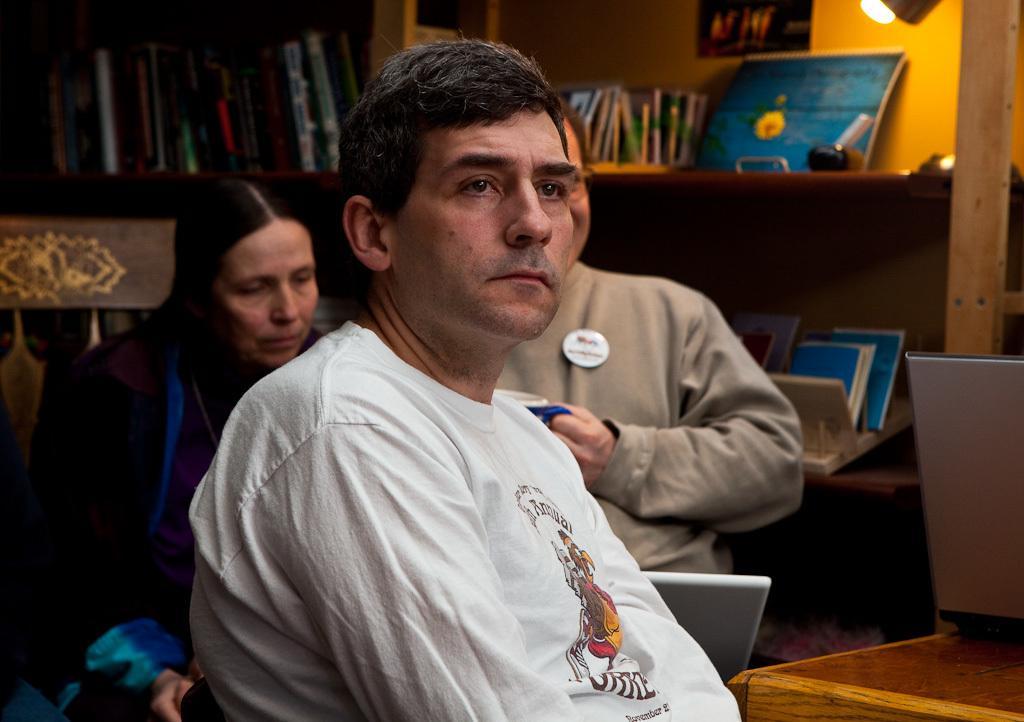In one or two sentences, can you explain what this image depicts? In this image there are three persons who are sitting. On the background there are some book racks are there and some books are there in the racks, and on the top of the right corner there is one light and in the bottom there is one laptop. 